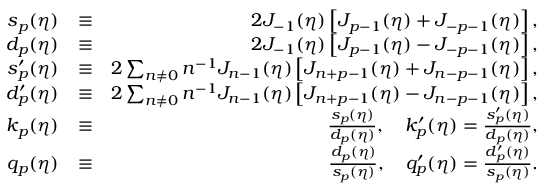Convert formula to latex. <formula><loc_0><loc_0><loc_500><loc_500>\begin{array} { r l r } { s _ { p } ( \eta ) } & { \equiv } & { 2 J _ { - 1 } ( \eta ) \left [ J _ { p - 1 } ( \eta ) + J _ { - p - 1 } ( \eta ) \right ] , } \\ { d _ { p } ( \eta ) } & { \equiv } & { 2 J _ { - 1 } ( \eta ) \left [ J _ { p - 1 } ( \eta ) - J _ { - p - 1 } ( \eta ) \right ] , } \\ { s _ { p } ^ { \prime } ( \eta ) } & { \equiv } & { 2 \sum _ { n \neq 0 } n ^ { - 1 } J _ { n - 1 } ( \eta ) \left [ J _ { n + p - 1 } ( \eta ) + J _ { n - p - 1 } ( \eta ) \right ] , } \\ { d _ { p } ^ { \prime } ( \eta ) } & { \equiv } & { 2 \sum _ { n \neq 0 } n ^ { - 1 } J _ { n - 1 } ( \eta ) \left [ J _ { n + p - 1 } ( \eta ) - J _ { n - p - 1 } ( \eta ) \right ] , } \\ { k _ { p } ( \eta ) } & { \equiv } & { \frac { s _ { p } ( \eta ) } { d _ { p } ( \eta ) } , \quad k _ { p } ^ { \prime } ( \eta ) = \frac { s _ { p } ^ { \prime } ( \eta ) } { d _ { p } ( \eta ) } , } \\ { q _ { p } ( \eta ) } & { \equiv } & { \frac { d _ { p } ( \eta ) } { s _ { p } ( \eta ) } , \quad q _ { p } ^ { \prime } ( \eta ) = \frac { d _ { p } ^ { \prime } ( \eta ) } { s _ { p } ( \eta ) } . } \end{array}</formula> 